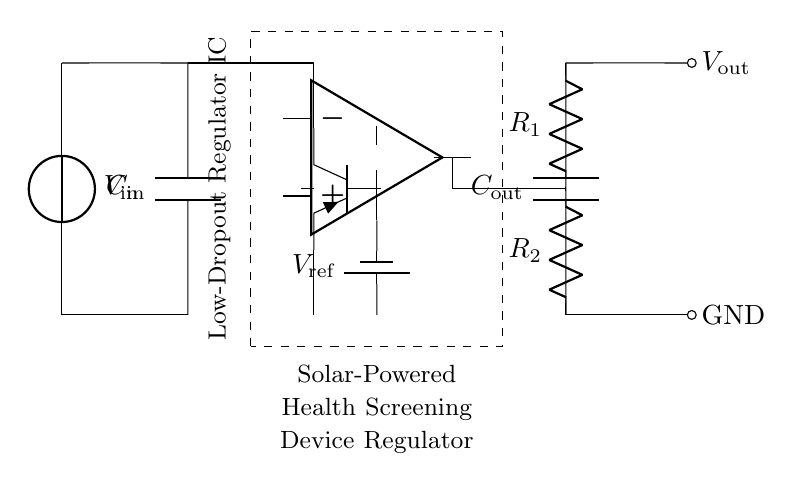What is the input voltage for this regulator circuit? The input voltage is represented by V_in, which is marked next to the voltage source at the beginning of the circuit.
Answer: V_in What are the values of the resistors in the feedback network? The circuit shows R_1 and R_2 in the feedback network. They are labeled next to their respective positions in the circuit diagram, indicating their values as part of the feedback loop.
Answer: R_1 and R_2 What is the function of the pass transistor in this circuit? The pass transistor is used to control the output voltage, ensuring it remains stable by adjusting its resistance based on the input conditions and feedback received from the error amplifier.
Answer: Control output voltage What type of regulator is represented in this circuit? The circuit is identified as a Low-Dropout Regulator, abbreviated as LDO, which is specified within the dashed rectangle containing the regulator components.
Answer: Low-Dropout Regulator What is the purpose of the input capacitor in this circuit? The input capacitor, labeled C_in, is employed to stabilize the input voltage at the regulator, filtering out noise and voltage fluctuations coming from the solar panel.
Answer: Stabilize input voltage How does the reference voltage affect the output of the regulator? The reference voltage, denoted as V_ref, is used by the error amplifier to determine the necessary adjustments of the pass transistor, thus maintaining the desired output voltage by comparing it to the feedback from the output.
Answer: Maintains desired output voltage What happens if the output capacitor is removed from the circuit? Removing the output capacitor, C_out, could lead to instability in the voltage output, resulting in voltage spikes or dips due to load changes and affecting the performance of the health screening device.
Answer: Causes instability 